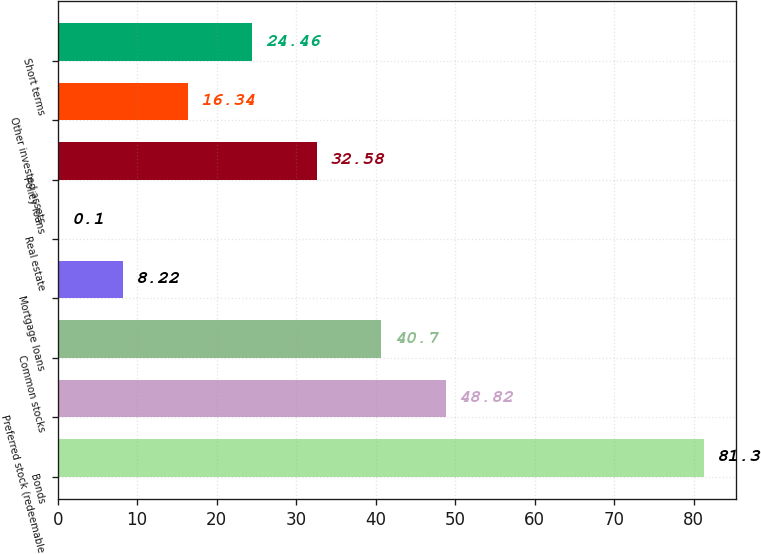<chart> <loc_0><loc_0><loc_500><loc_500><bar_chart><fcel>Bonds<fcel>Preferred stock (redeemable<fcel>Common stocks<fcel>Mortgage loans<fcel>Real estate<fcel>Policy loans<fcel>Other invested assets<fcel>Short terms<nl><fcel>81.3<fcel>48.82<fcel>40.7<fcel>8.22<fcel>0.1<fcel>32.58<fcel>16.34<fcel>24.46<nl></chart> 